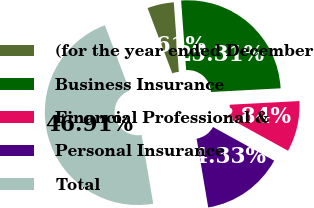Convert chart to OTSL. <chart><loc_0><loc_0><loc_500><loc_500><pie_chart><fcel>(for the year ended December<fcel>Business Insurance<fcel>Financial Professional &<fcel>Personal Insurance<fcel>Total<nl><fcel>4.61%<fcel>25.31%<fcel>8.84%<fcel>14.33%<fcel>46.91%<nl></chart> 